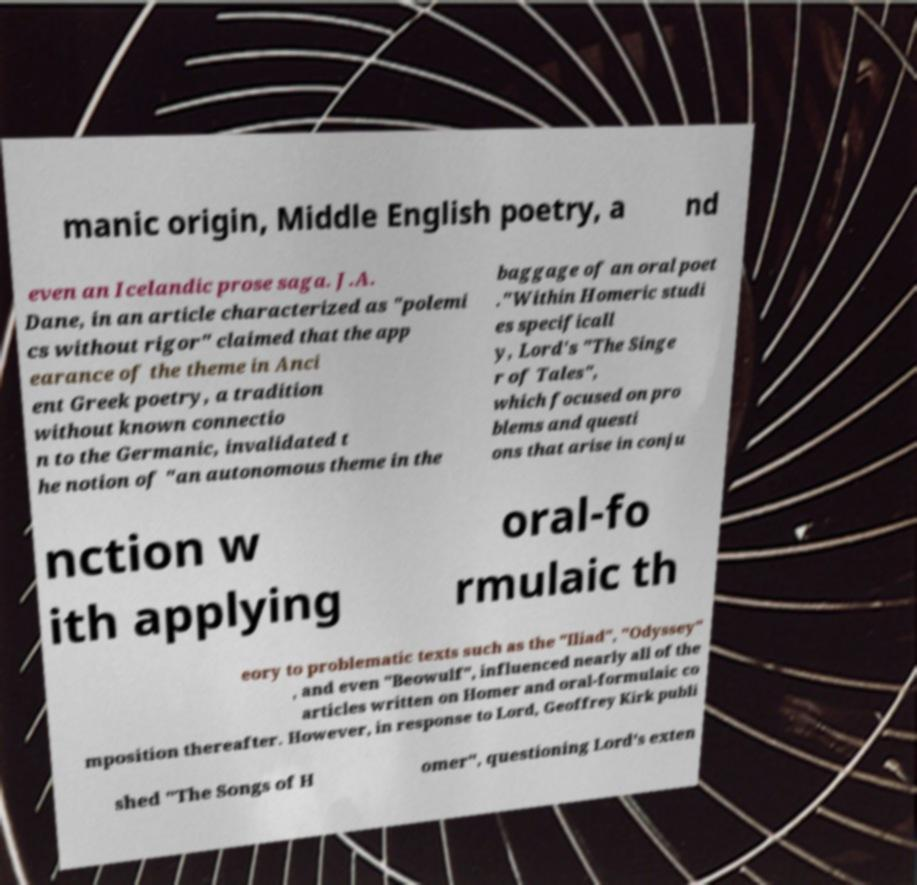Could you assist in decoding the text presented in this image and type it out clearly? manic origin, Middle English poetry, a nd even an Icelandic prose saga. J.A. Dane, in an article characterized as "polemi cs without rigor" claimed that the app earance of the theme in Anci ent Greek poetry, a tradition without known connectio n to the Germanic, invalidated t he notion of "an autonomous theme in the baggage of an oral poet ."Within Homeric studi es specificall y, Lord's "The Singe r of Tales", which focused on pro blems and questi ons that arise in conju nction w ith applying oral-fo rmulaic th eory to problematic texts such as the "Iliad", "Odyssey" , and even "Beowulf", influenced nearly all of the articles written on Homer and oral-formulaic co mposition thereafter. However, in response to Lord, Geoffrey Kirk publi shed "The Songs of H omer", questioning Lord's exten 